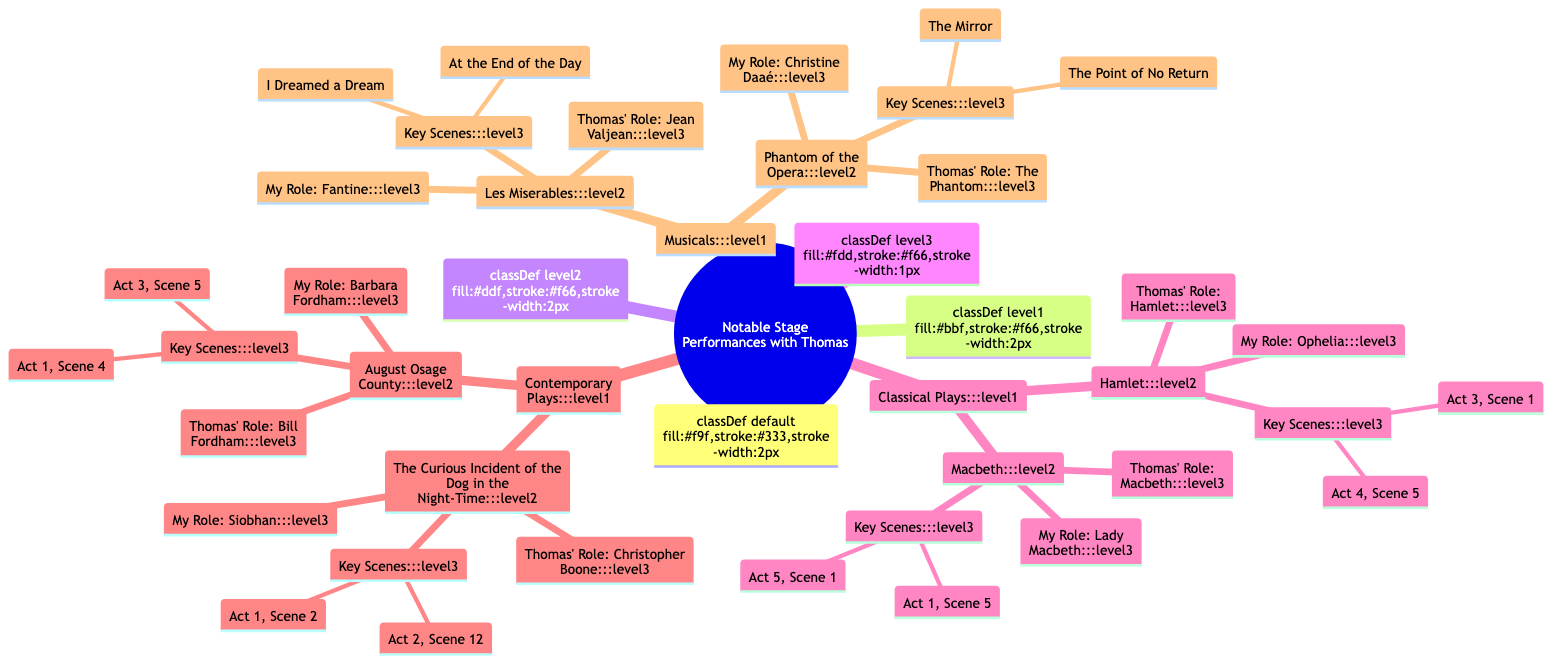What roles did Thomas play in Classical Plays? According to the diagram, Thomas played Hamlet in 'Hamlet' and Macbeth in 'Macbeth'.
Answer: Hamlet, Macbeth How many key scenes are there in 'Les Miserables'? The diagram lists two key scenes for 'Les Miserables', which are 'At the End of the Day' and 'I Dreamed a Dream'.
Answer: 2 Which role did I play in 'The Curious Incident of the Dog in the Night-Time'? The diagram states that you played Siobhan in 'The Curious Incident of the Dog in the Night-Time'.
Answer: Siobhan What are the key scenes from 'Macbeth'? The diagram mentions the key scenes from 'Macbeth' as 'Act 1, Scene 5' and 'Act 5, Scene 1'.
Answer: Act 1, Scene 5; Act 5, Scene 1 Who played the role of Christine Daaé in 'Phantom of the Opera'? According to the diagram, you played the role of Christine Daaé in 'Phantom of the Opera'.
Answer: You What type of plays are classified under Contemporary Plays? The diagram includes 'The Curious Incident of the Dog in the Night-Time' and 'August Osage County' under the category of Contemporary Plays.
Answer: The Curious Incident of the Dog in the Night-Time, August Osage County In how many musicals did Thomas play? The diagram shows that Thomas played in two musicals, 'Les Miserables' and 'Phantom of the Opera'.
Answer: 2 Which role did Thomas play in 'August Osage County'? The diagram indicates that Thomas played Bill Fordham in 'August Osage County'.
Answer: Bill Fordham What is the relationship between my role and Thomas' role in 'Hamlet'? The diagram shows that you played Ophelia while Thomas played Hamlet in 'Hamlet', indicating a significant relational dynamic between the characters.
Answer: Ophelia; Hamlet What is the thematic focus of Classical Plays in the diagram? The diagram showcases the Classical Plays category, featuring works by Shakespeare, namely, 'Hamlet' and 'Macbeth'.
Answer: Shakespeare's tragedies 